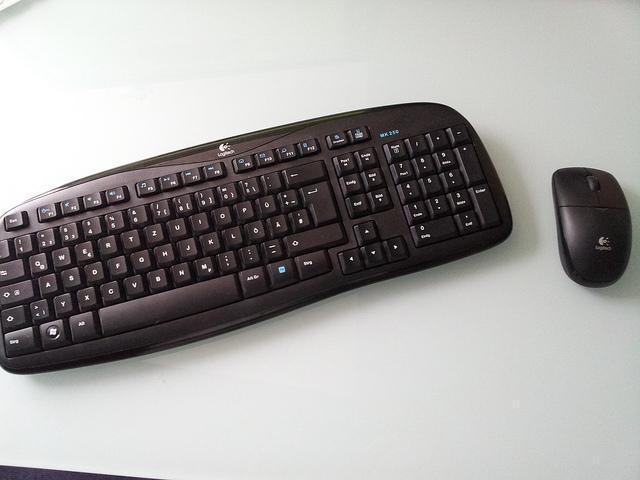How many motors does the boat have?
Give a very brief answer. 0. 